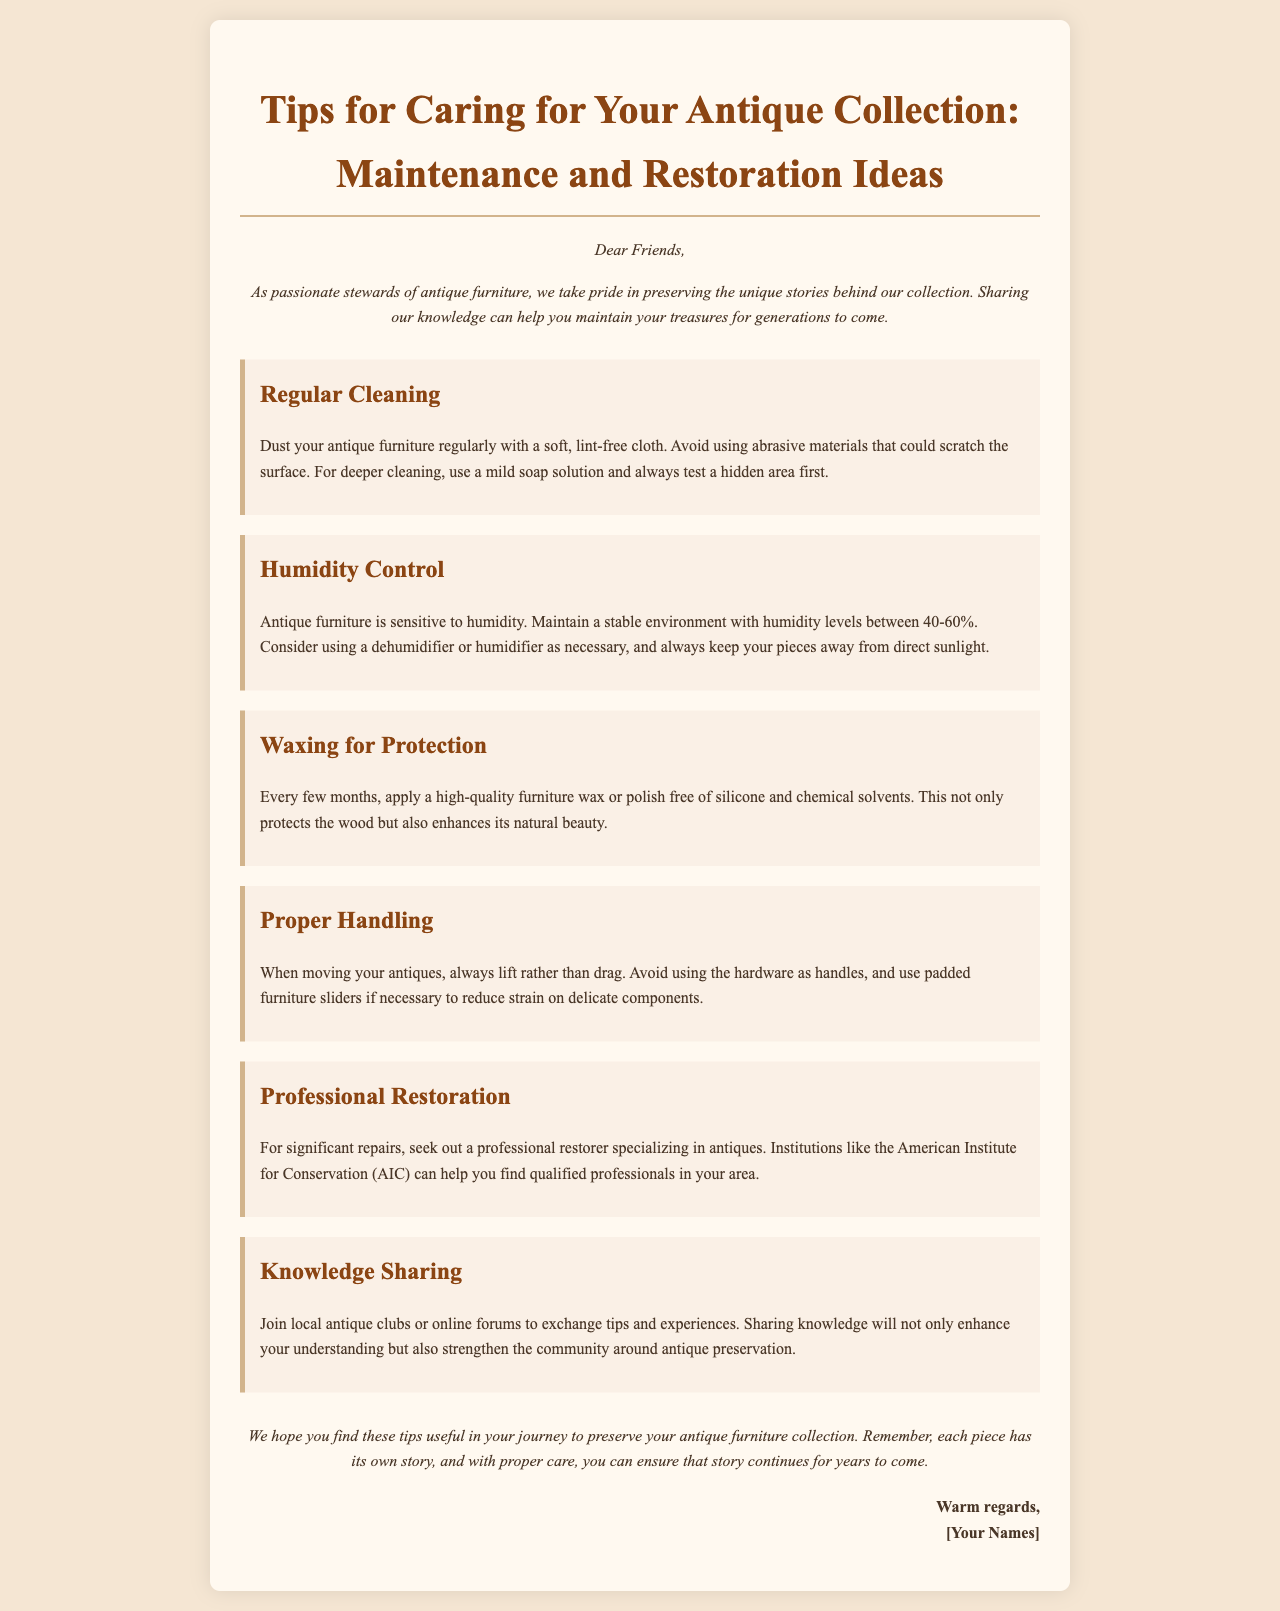What is the title of the newsletter? The title is prominently displayed at the top of the document, indicating the focus of the content.
Answer: Tips for Caring for Your Antique Collection: Maintenance and Restoration Ideas What should you regularly use to dust antique furniture? The document mentions a specific type of cloth suitable for cleaning to avoid damage to the surfaces.
Answer: Soft, lint-free cloth What humidity levels are recommended for antique furniture? The document specifies a range of humidity levels that are ideal for maintaining antique pieces.
Answer: 40-60% How often should you apply furniture wax? The document provides a timeline for how frequently to protect the wood using wax or polish.
Answer: Every few months What organization can help find professional restorers? The document references a specific organization that aids in locating qualified professionals for restoration.
Answer: American Institute for Conservation Why is it important to lift antique furniture rather than drag it? The document explains the rationale behind proper handling methods to protect the furniture.
Answer: Reduce strain on delicate components What type of clubs can you join to enhance your knowledge of antiques? The document suggests specific types of groups that are beneficial for learning and sharing within the antique community.
Answer: Local antique clubs or online forums What aesthetic benefit does waxing provide to antique furniture? The document highlights an additional advantage of waxing beyond protection.
Answer: Enhances its natural beauty 